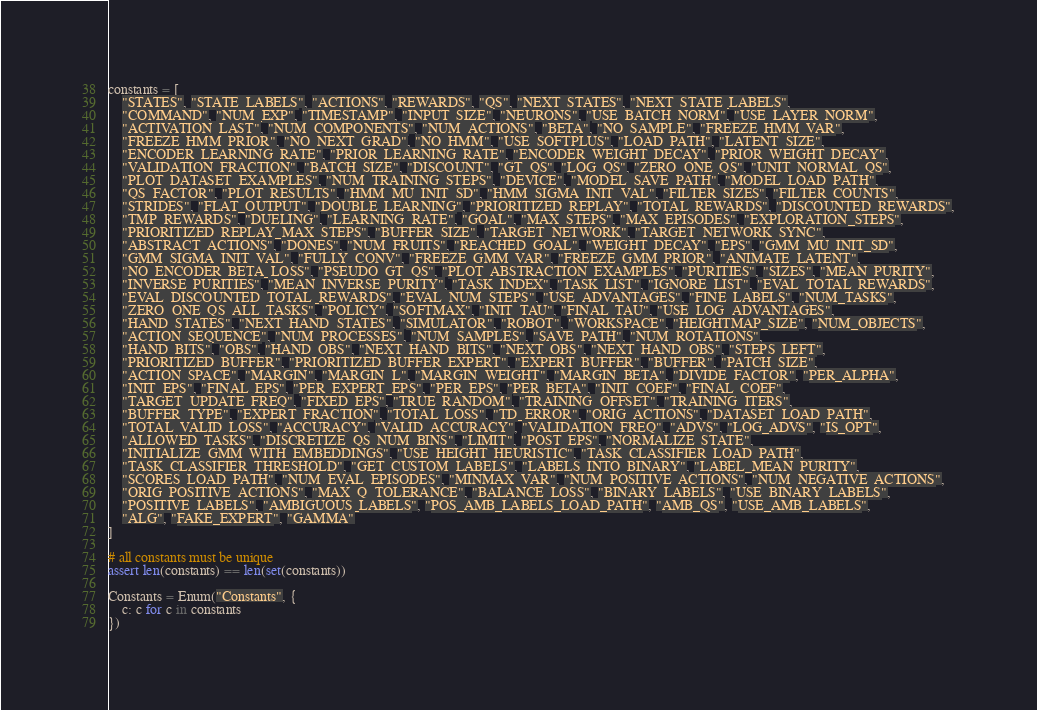Convert code to text. <code><loc_0><loc_0><loc_500><loc_500><_Python_>
constants = [
    "STATES", "STATE_LABELS", "ACTIONS", "REWARDS", "QS", "NEXT_STATES", "NEXT_STATE_LABELS",
    "COMMAND", "NUM_EXP", "TIMESTAMP", "INPUT_SIZE", "NEURONS", "USE_BATCH_NORM", "USE_LAYER_NORM",
    "ACTIVATION_LAST", "NUM_COMPONENTS", "NUM_ACTIONS", "BETA", "NO_SAMPLE", "FREEZE_HMM_VAR",
    "FREEZE_HMM_PRIOR", "NO_NEXT_GRAD", "NO_HMM", "USE_SOFTPLUS", "LOAD_PATH", "LATENT_SIZE",
    "ENCODER_LEARNING_RATE", "PRIOR_LEARNING_RATE", "ENCODER_WEIGHT_DECAY", "PRIOR_WEIGHT_DECAY",
    "VALIDATION_FRACTION", "BATCH_SIZE", "DISCOUNT", "GT_QS", "LOG_QS", "ZERO_ONE_QS", "UNIT_NORMAL_QS",
    "PLOT_DATASET_EXAMPLES", "NUM_TRAINING_STEPS", "DEVICE", "MODEL_SAVE_PATH", "MODEL_LOAD_PATH",
    "QS_FACTOR", "PLOT_RESULTS", "HMM_MU_INIT_SD", "HMM_SIGMA_INIT_VAL", "FILTER_SIZES", "FILTER_COUNTS",
    "STRIDES", "FLAT_OUTPUT", "DOUBLE_LEARNING", "PRIORITIZED_REPLAY", "TOTAL_REWARDS", "DISCOUNTED_REWARDS",
    "TMP_REWARDS", "DUELING", "LEARNING_RATE", "GOAL", "MAX_STEPS", "MAX_EPISODES", "EXPLORATION_STEPS",
    "PRIORITIZED_REPLAY_MAX_STEPS", "BUFFER_SIZE", "TARGET_NETWORK", "TARGET_NETWORK_SYNC",
    "ABSTRACT_ACTIONS", "DONES", "NUM_FRUITS", "REACHED_GOAL", "WEIGHT_DECAY", "EPS", "GMM_MU_INIT_SD",
    "GMM_SIGMA_INIT_VAL", "FULLY_CONV", "FREEZE_GMM_VAR", "FREEZE_GMM_PRIOR", "ANIMATE_LATENT",
    "NO_ENCODER_BETA_LOSS", "PSEUDO_GT_QS", "PLOT_ABSTRACTION_EXAMPLES", "PURITIES", "SIZES", "MEAN_PURITY",
    "INVERSE_PURITIES", "MEAN_INVERSE_PURITY", "TASK_INDEX", "TASK_LIST", "IGNORE_LIST", "EVAL_TOTAL_REWARDS",
    "EVAL_DISCOUNTED_TOTAL_REWARDS", "EVAL_NUM_STEPS", "USE_ADVANTAGES", "FINE_LABELS", "NUM_TASKS",
    "ZERO_ONE_QS_ALL_TASKS", "POLICY", "SOFTMAX", "INIT_TAU", "FINAL_TAU", "USE_LOG_ADVANTAGES",
    "HAND_STATES", "NEXT_HAND_STATES", "SIMULATOR", "ROBOT", "WORKSPACE", "HEIGHTMAP_SIZE", "NUM_OBJECTS",
    "ACTION_SEQUENCE", "NUM_PROCESSES", "NUM_SAMPLES", "SAVE_PATH", "NUM_ROTATIONS",
    "HAND_BITS", "OBS", "HAND_OBS", "NEXT_HAND_BITS", "NEXT_OBS", "NEXT_HAND_OBS", "STEPS_LEFT",
    "PRIORITIZED_BUFFER", "PRIORITIZED_BUFFER_EXPERT", "EXPERT_BUFFER", "BUFFER", "PATCH_SIZE",
    "ACTION_SPACE", "MARGIN", "MARGIN_L", "MARGIN_WEIGHT", "MARGIN_BETA", "DIVIDE_FACTOR", "PER_ALPHA",
    "INIT_EPS", "FINAL_EPS", "PER_EXPERT_EPS", "PER_EPS", "PER_BETA", "INIT_COEF", "FINAL_COEF",
    "TARGET_UPDATE_FREQ", "FIXED_EPS", "TRUE_RANDOM", "TRAINING_OFFSET", "TRAINING_ITERS",
    "BUFFER_TYPE", "EXPERT_FRACTION", "TOTAL_LOSS", "TD_ERROR", "ORIG_ACTIONS", "DATASET_LOAD_PATH",
    "TOTAL_VALID_LOSS", "ACCURACY", "VALID_ACCURACY", "VALIDATION_FREQ", "ADVS", "LOG_ADVS", "IS_OPT",
    "ALLOWED_TASKS", "DISCRETIZE_QS_NUM_BINS", "LIMIT", "POST_EPS", "NORMALIZE_STATE",
    "INITIALIZE_GMM_WITH_EMBEDDINGS", "USE_HEIGHT_HEURISTIC", "TASK_CLASSIFIER_LOAD_PATH",
    "TASK_CLASSIFIER_THRESHOLD", "GET_CUSTOM_LABELS", "LABELS_INTO_BINARY", "LABEL_MEAN_PURITY",
    "SCORES_LOAD_PATH", "NUM_EVAL_EPISODES", "MINMAX_VAR", "NUM_POSITIVE_ACTIONS", "NUM_NEGATIVE_ACTIONS",
    "ORIG_POSITIVE_ACTIONS", "MAX_Q_TOLERANCE", "BALANCE_LOSS", "BINARY_LABELS", "USE_BINARY_LABELS",
    "POSITIVE_LABELS", "AMBIGUOUS_LABELS", "POS_AMB_LABELS_LOAD_PATH", "AMB_QS", "USE_AMB_LABELS",
    "ALG", "FAKE_EXPERT", "GAMMA"
]

# all constants must be unique
assert len(constants) == len(set(constants))

Constants = Enum("Constants", {
    c: c for c in constants
})

</code> 